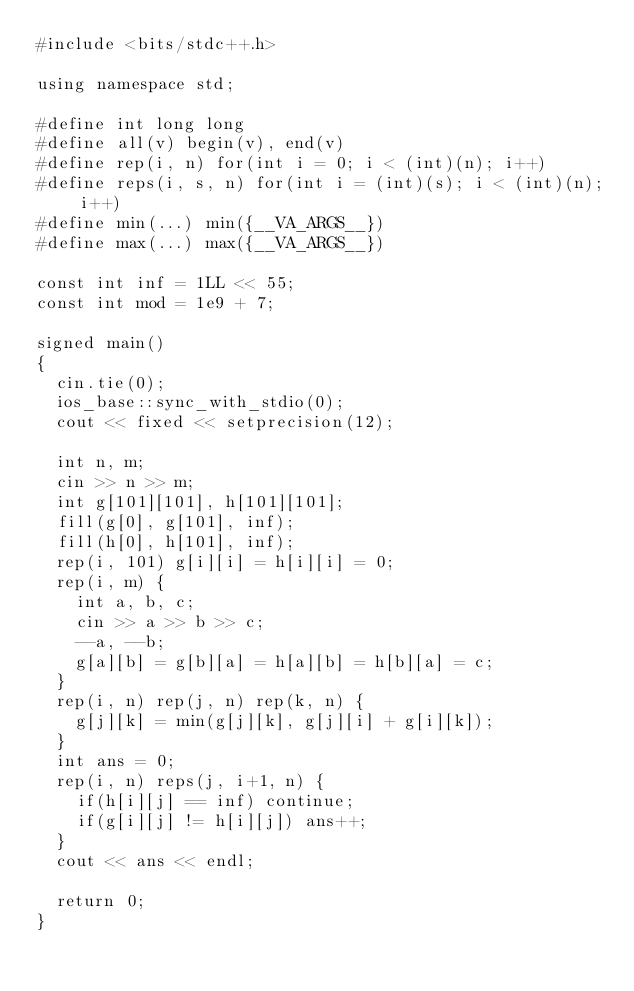Convert code to text. <code><loc_0><loc_0><loc_500><loc_500><_C++_>#include <bits/stdc++.h>

using namespace std;

#define int long long
#define all(v) begin(v), end(v)
#define rep(i, n) for(int i = 0; i < (int)(n); i++)
#define reps(i, s, n) for(int i = (int)(s); i < (int)(n); i++)
#define min(...) min({__VA_ARGS__})
#define max(...) max({__VA_ARGS__})

const int inf = 1LL << 55;
const int mod = 1e9 + 7;

signed main()
{
  cin.tie(0);
  ios_base::sync_with_stdio(0);
  cout << fixed << setprecision(12);

  int n, m;
  cin >> n >> m;
  int g[101][101], h[101][101];
  fill(g[0], g[101], inf);
  fill(h[0], h[101], inf);
  rep(i, 101) g[i][i] = h[i][i] = 0;
  rep(i, m) {
    int a, b, c;
    cin >> a >> b >> c;
    --a, --b;
    g[a][b] = g[b][a] = h[a][b] = h[b][a] = c;
  }
  rep(i, n) rep(j, n) rep(k, n) {
    g[j][k] = min(g[j][k], g[j][i] + g[i][k]);
  }
  int ans = 0;
  rep(i, n) reps(j, i+1, n) {
    if(h[i][j] == inf) continue;
    if(g[i][j] != h[i][j]) ans++;
  }
  cout << ans << endl;

  return 0;
}
</code> 